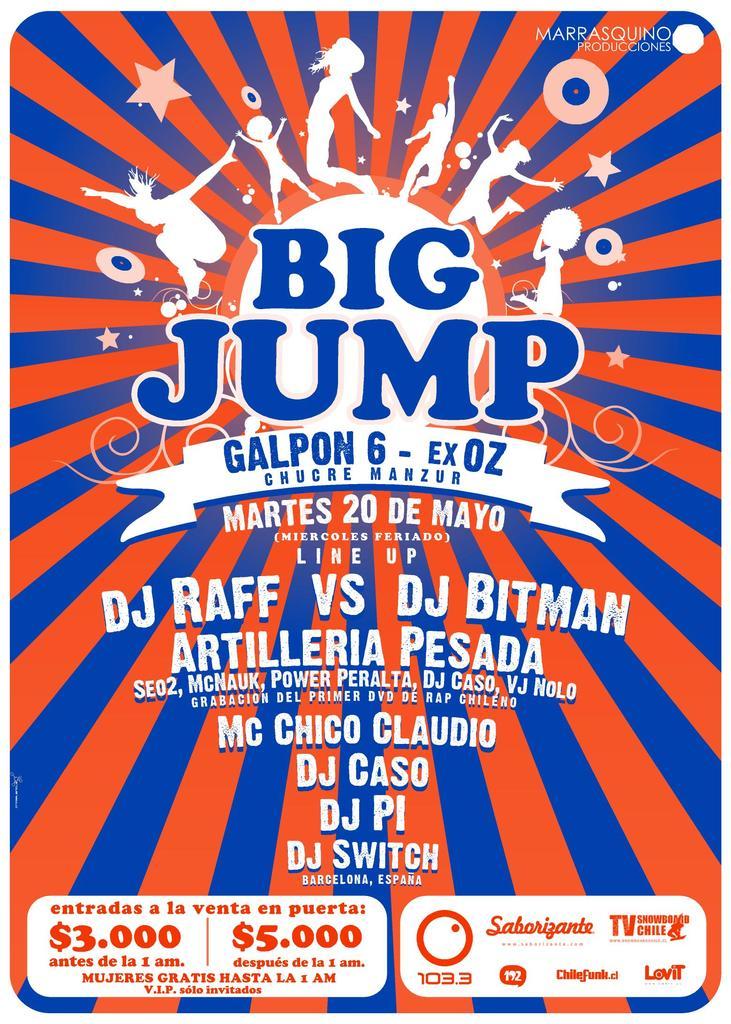What is the name of this show?
Make the answer very short. Big jump. In what month does the show take place?
Ensure brevity in your answer.  May. 